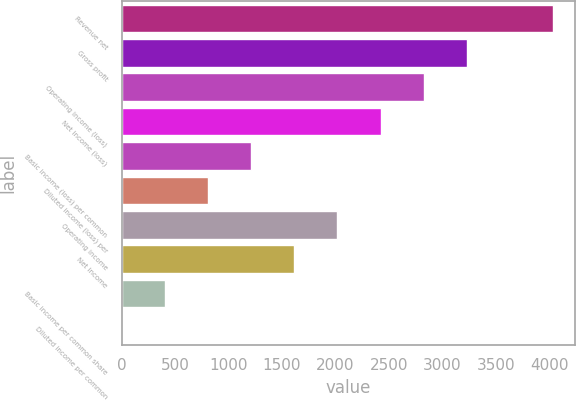Convert chart. <chart><loc_0><loc_0><loc_500><loc_500><bar_chart><fcel>Revenue net<fcel>Gross profit<fcel>Operating income (loss)<fcel>Net income (loss)<fcel>Basic income (loss) per common<fcel>Diluted income (loss) per<fcel>Operating income<fcel>Net income<fcel>Basic income per common share<fcel>Diluted income per common<nl><fcel>4035<fcel>3228.21<fcel>2824.81<fcel>2421.41<fcel>1211.21<fcel>807.81<fcel>2018.01<fcel>1614.61<fcel>404.41<fcel>1.01<nl></chart> 